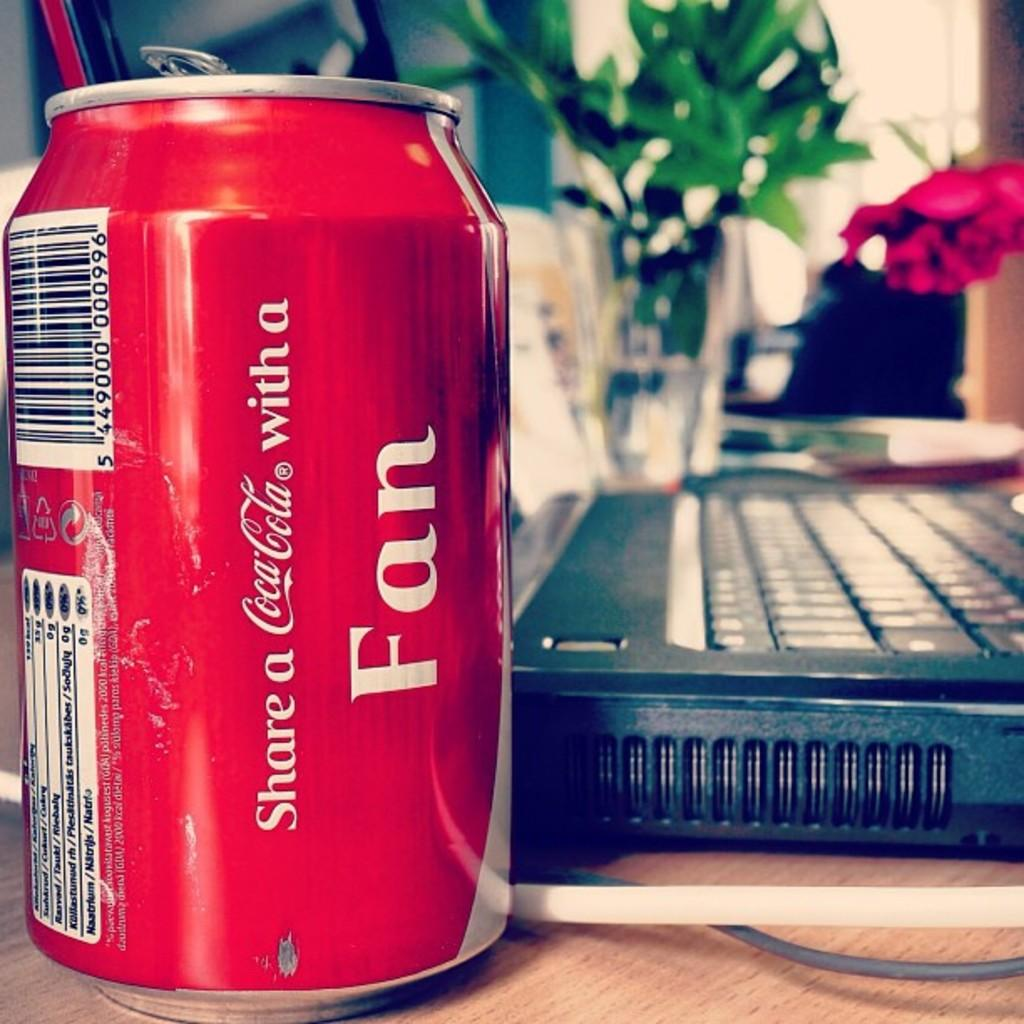Provide a one-sentence caption for the provided image. Coca cola can that is next to a laptop computer. 